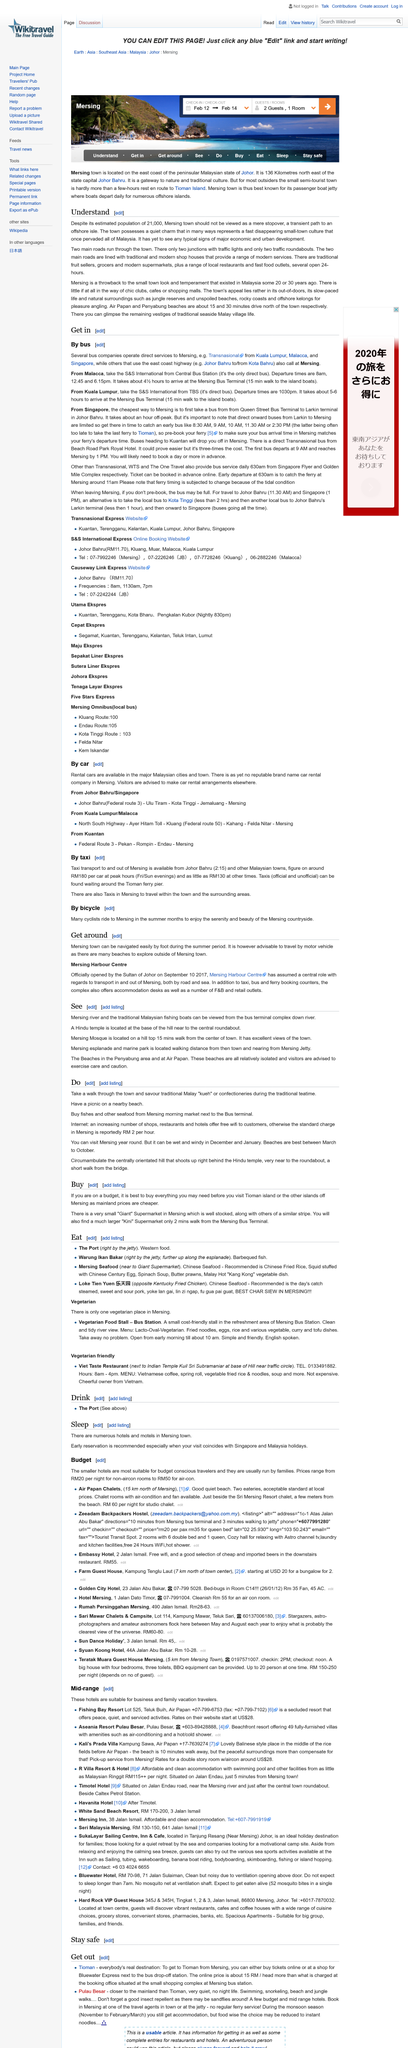Identify some key points in this picture. Peak times on Friday and Sunday evenings result in a taxi ride costing RM180. The Mersing Harbour Centre officially opened on September 10, 2017. The Hindu temple is located near the central roundabout, at the base of the hill, where it can be easily accessed. Mersing, a town in Malaysia, is mentioned three times in the article. The Mersing Harbour Centre was opened by the Sultan of Johor. 